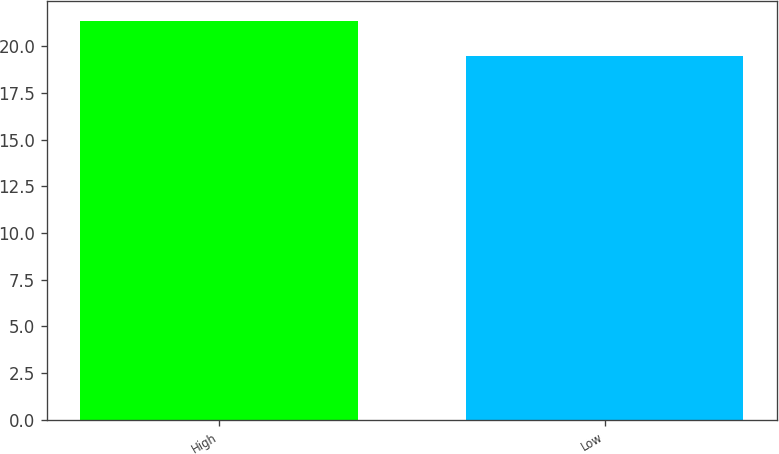Convert chart. <chart><loc_0><loc_0><loc_500><loc_500><bar_chart><fcel>High<fcel>Low<nl><fcel>21.37<fcel>19.5<nl></chart> 